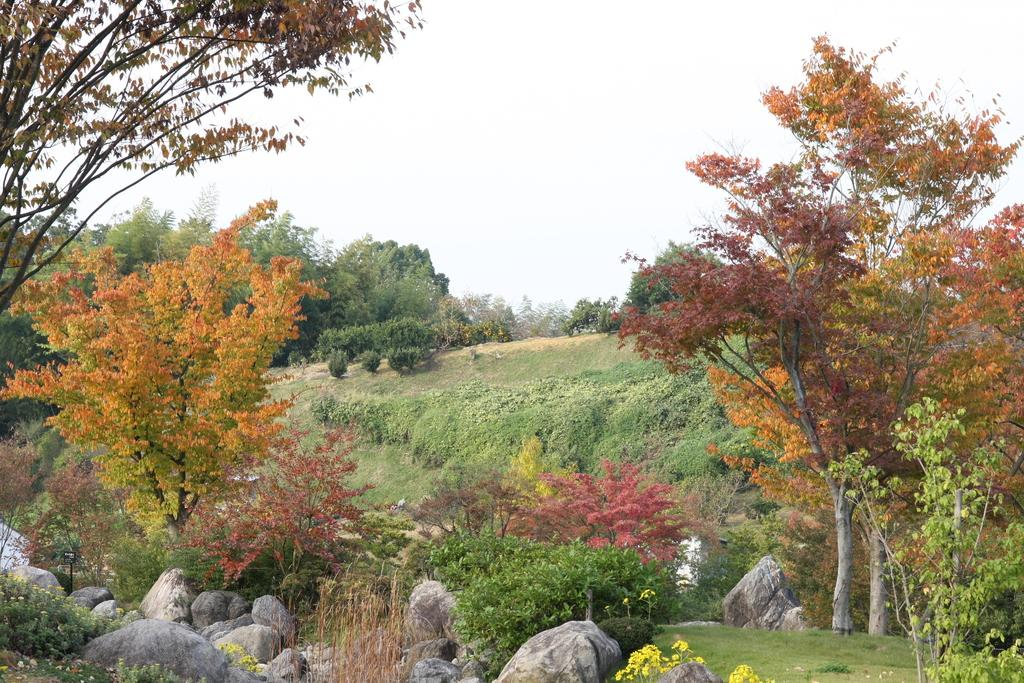What type of natural elements can be seen in the image? There are rocks, plants, and grass on the ground in the image. Where are the trees located in the image? There are trees on both the left and right sides of the image. What type of vegetation is present in the image? In addition to trees, there are plants visible in the image. What type of amusement can be seen in the image? There is no amusement present in the image; it features natural elements such as rocks, plants, grass, and trees. 